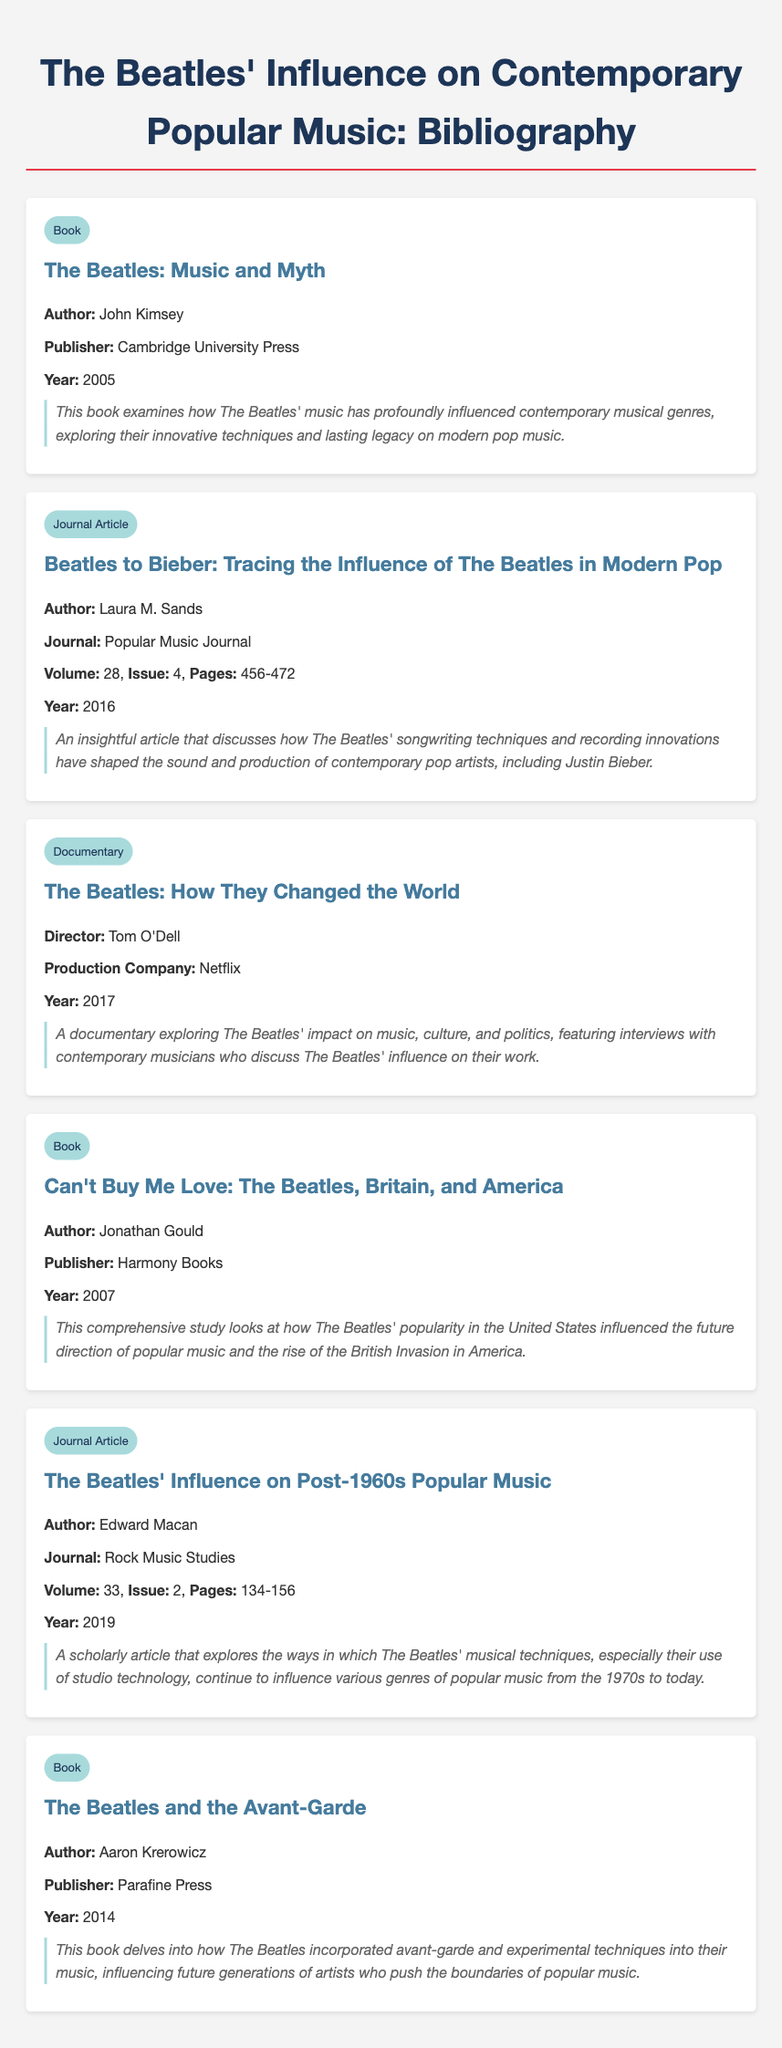what is the title of the first book listed? The title of the first book is provided in the bibliographic entry, which is "The Beatles: Music and Myth."
Answer: The Beatles: Music and Myth who is the author of the article published in the Popular Music Journal? The author's name can be found in the journal article citation, which is Laura M. Sands.
Answer: Laura M. Sands what year was "Can't Buy Me Love: The Beatles, Britain, and America" published? The publication year is stated in the bibliographic entry, which shows it was published in 2007.
Answer: 2007 what type of document is "The Beatles: How They Changed the World"? The type of document is identified in the entry, indicating it is a documentary.
Answer: Documentary how many pages does the article "The Beatles' Influence on Post-1960s Popular Music" span? The number of pages is mentioned in the entry, which states it is from pages 134 to 156 (a total of 23 pages).
Answer: 23 pages who directed the documentary about The Beatles' influence? The director's name is listed in the bibliographic entry as Tom O'Dell.
Answer: Tom O'Dell what is the main subject of the book "The Beatles and the Avant-Garde"? The main subject is briefly summarized in the description, which indicates it explores avant-garde influences in The Beatles' music.
Answer: Avant-garde influences in which publisher was "The Beatles: Music and Myth" published? The publisher's name is noted in the bibliographic entry, which is Cambridge University Press.
Answer: Cambridge University Press 